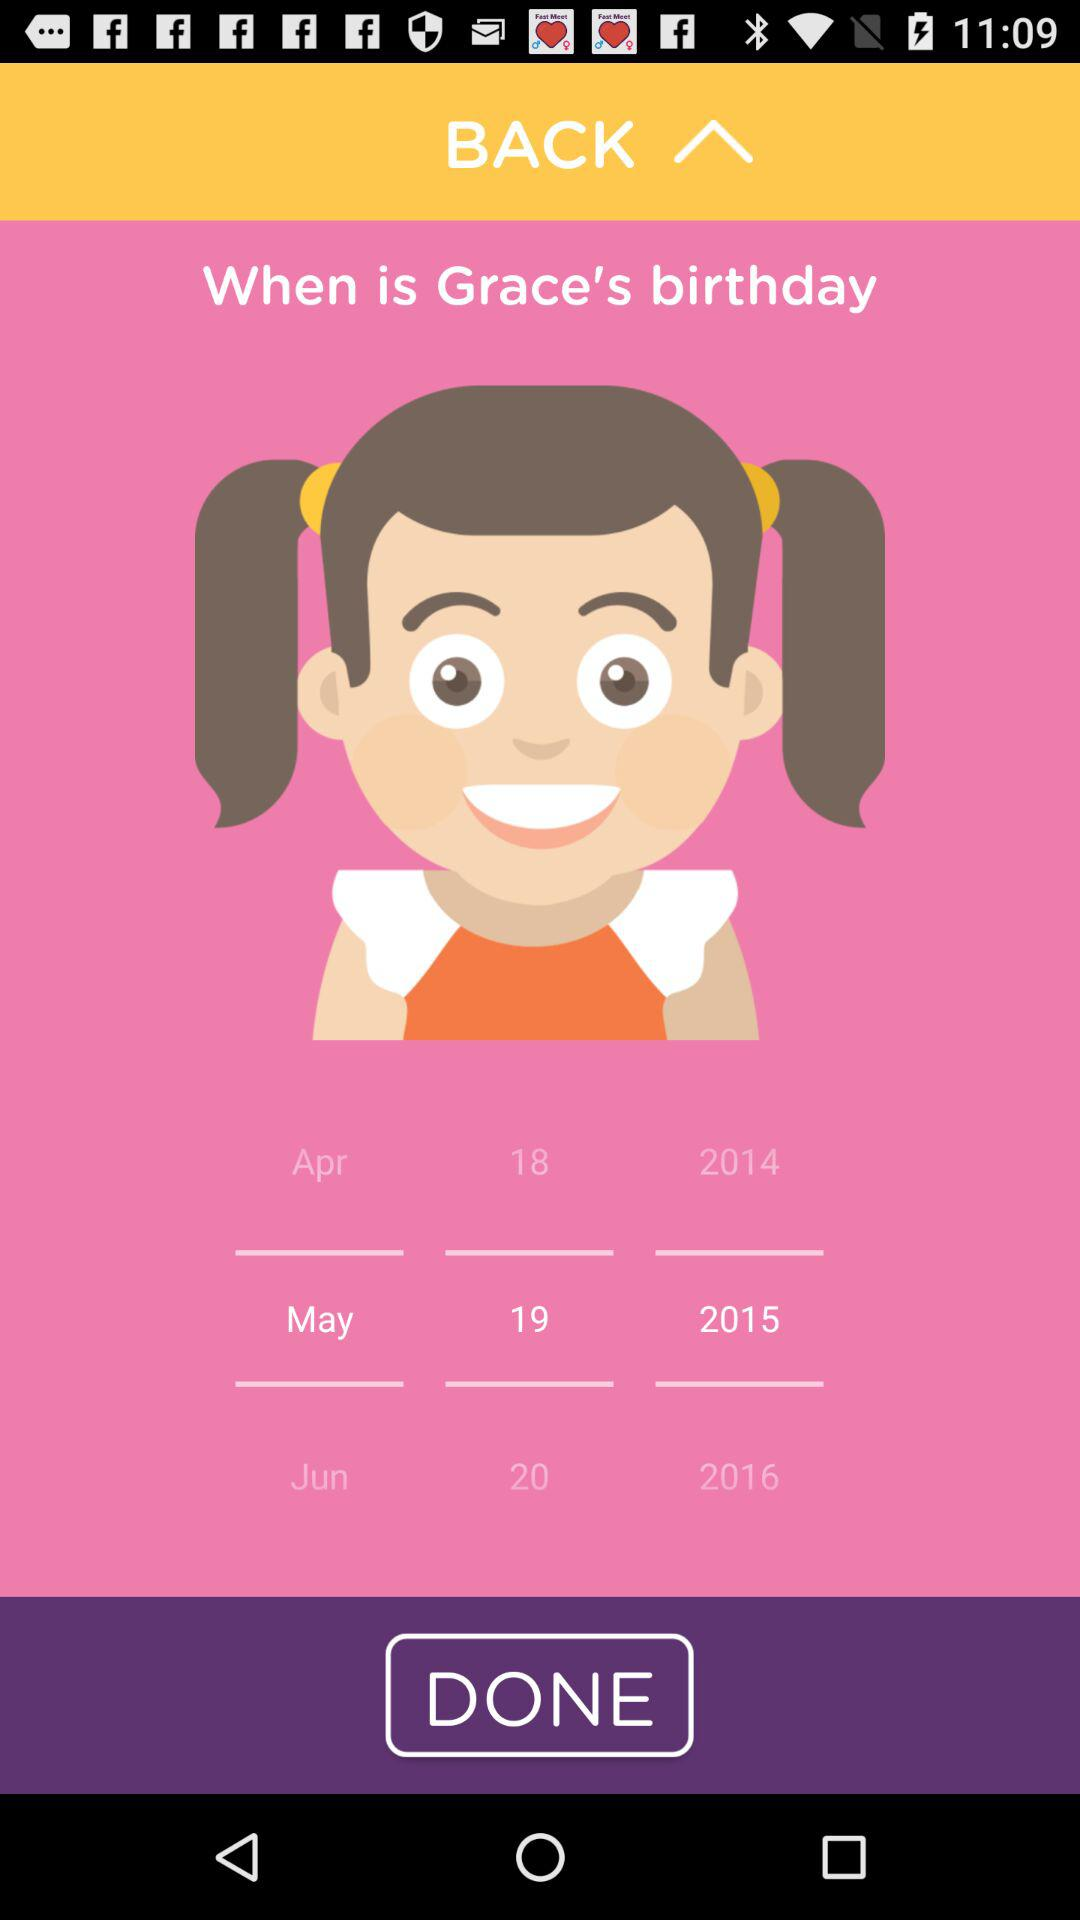What is the girl name whose date of birth is given? The girl name is Grace. 